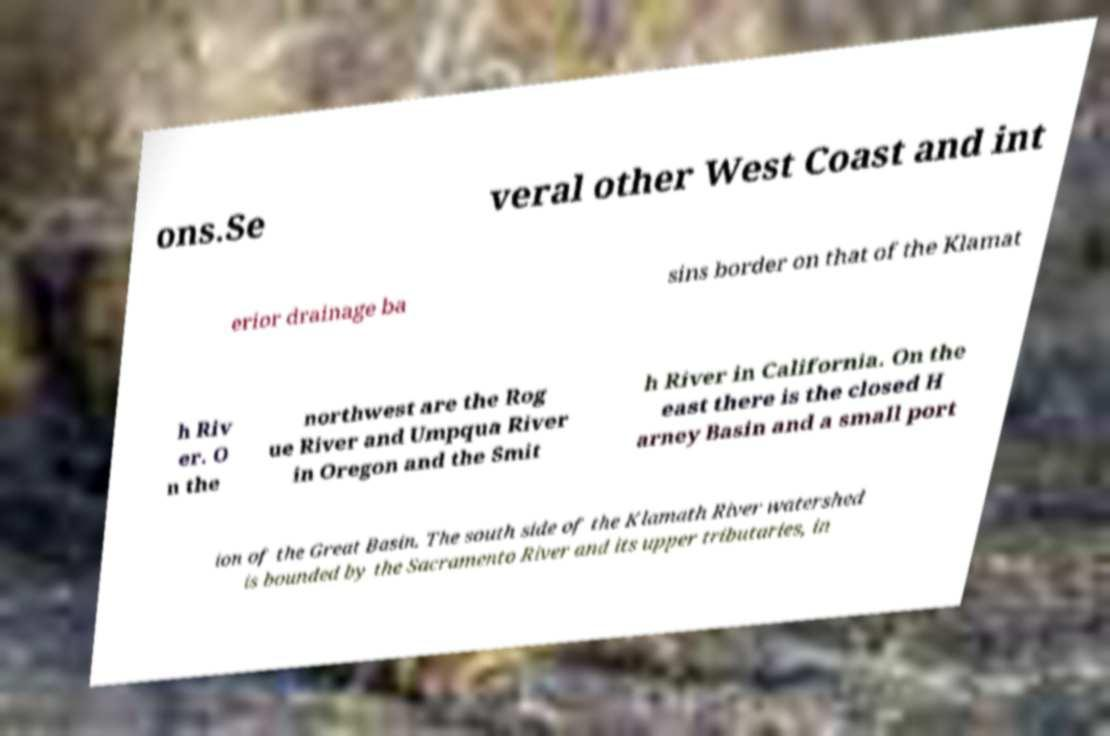Can you accurately transcribe the text from the provided image for me? ons.Se veral other West Coast and int erior drainage ba sins border on that of the Klamat h Riv er. O n the northwest are the Rog ue River and Umpqua River in Oregon and the Smit h River in California. On the east there is the closed H arney Basin and a small port ion of the Great Basin. The south side of the Klamath River watershed is bounded by the Sacramento River and its upper tributaries, in 